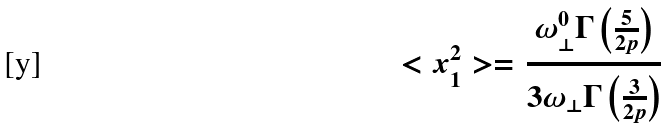Convert formula to latex. <formula><loc_0><loc_0><loc_500><loc_500>< x _ { 1 } ^ { 2 } > = \frac { \omega _ { \bot } ^ { 0 } \Gamma \left ( \frac { 5 } { 2 p } \right ) } { 3 \omega _ { \bot } \Gamma \left ( \frac { 3 } { 2 p } \right ) }</formula> 